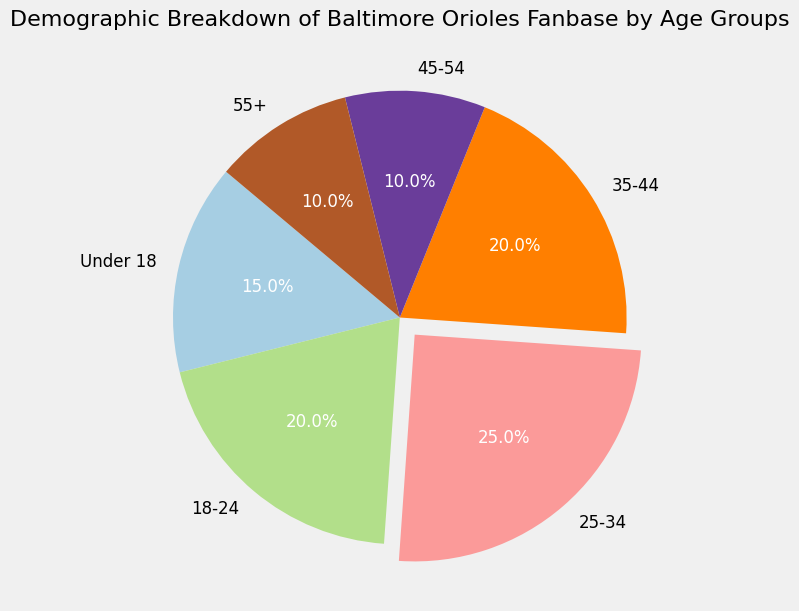What age group has the largest percentage of fans? The largest segment in the pie chart is highlighted with an explosion and autopct label. By looking at the chart, the largest slice represents the 25-34 age group.
Answer: 25-34 How many age groups have a percentage of fans equal to or greater than 20%? By observing the percentage labels on the pie chart, the age groups with 20% or more are 18-24 (20%), 25-34 (25%), and 35-44 (20%). This totals three groups.
Answer: 3 What is the combined percentage of fans aged 45 and above? To find this, sum the percentages of the 45-54 and 55+ age groups: \( 10\% (45-54) + 10\% (55+) = 20\% \).
Answer: 20% Which color represents the 18-24 age group in the pie chart? By examining the pie chart's color distribution, we identify that the 18-24 age group is typically labeled and colored distinctly in the chart (often shown as a different hue), e.g., green.
Answer: green What is the difference in the percentage of fans between the age groups 25-34 and 45-54? Subtract the percentage of the 45-54 age group (10%) from the 25-34 age group (25%): \( 25\% - 10\% = 15\% \).
Answer: 15% Which age group has the second smallest percentage of fans? By observing the pie chart, identify that the age groups with the smallest percentages are 45-54 and 55+, both at 10%. Since they are tied, the next smallest percentage would be those under 18, at 15%. Thus, the second smallest is tied between 45-54 and 55+.
Answer: 45-54 and 55+ If you combined the percentages of the under 18 and 35-44 age groups, what would be the total percentage? Add the percentages of the under 18 (15%) and 35-44 (20%) age groups: \( 15\% + 20\% = 35\% \).
Answer: 35% What percentage of fans are between 18 and 44 years old? Add the percentages of the 18-24 (20%), 25-34 (25%), and 35-44 (20%) age groups: \( 20\% + 25\% + 20\% = 65\% \).
Answer: 65% Which age group has a percentage equal to the sum of the 45-54 and 55+ age groups' percentages? The sum of the percentages of the 45-54 (10%) and 55+ (10%) age groups is \( 10\% + 10\% = 20\% \). The age group that also has 20% is the 18-24 and 35-44 groups.
Answer: 18-24 and 35-44 